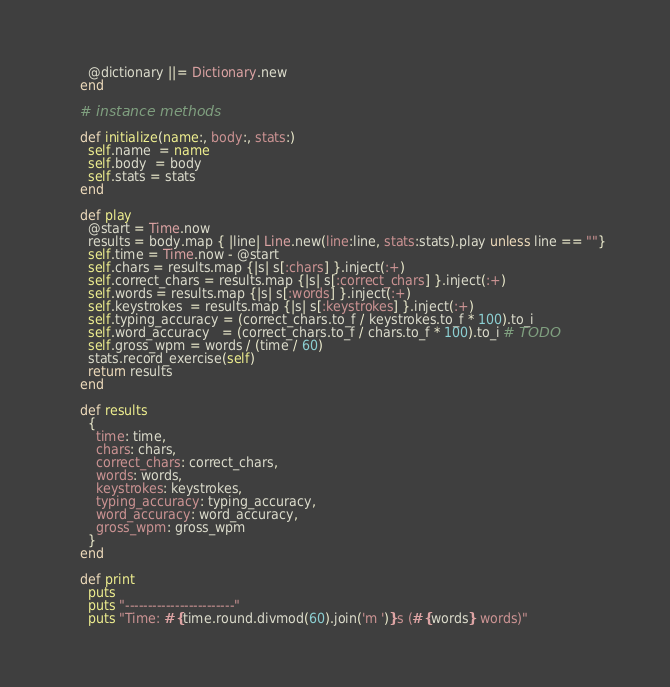Convert code to text. <code><loc_0><loc_0><loc_500><loc_500><_Ruby_>      @dictionary ||= Dictionary.new
    end

    # instance methods

    def initialize(name:, body:, stats:)
      self.name  = name
      self.body  = body
      self.stats = stats
    end

    def play
      @start = Time.now
      results = body.map { |line| Line.new(line:line, stats:stats).play unless line == ""}
      self.time = Time.now - @start
      self.chars = results.map {|s| s[:chars] }.inject(:+)
      self.correct_chars = results.map {|s| s[:correct_chars] }.inject(:+)
      self.words = results.map {|s| s[:words] }.inject(:+)
      self.keystrokes  = results.map {|s| s[:keystrokes] }.inject(:+)
      self.typing_accuracy = (correct_chars.to_f / keystrokes.to_f * 100).to_i
      self.word_accuracy   = (correct_chars.to_f / chars.to_f * 100).to_i # TODO
      self.gross_wpm = words / (time / 60)
      stats.record_exercise(self)
      return results
    end

    def results
      {
        time: time,
        chars: chars,
        correct_chars: correct_chars,
        words: words,
        keystrokes: keystrokes,
        typing_accuracy: typing_accuracy,
        word_accuracy: word_accuracy,
        gross_wpm: gross_wpm
      }
    end

    def print
      puts
      puts "------------------------"
      puts "Time: #{time.round.divmod(60).join('m ')}s (#{words} words)"</code> 